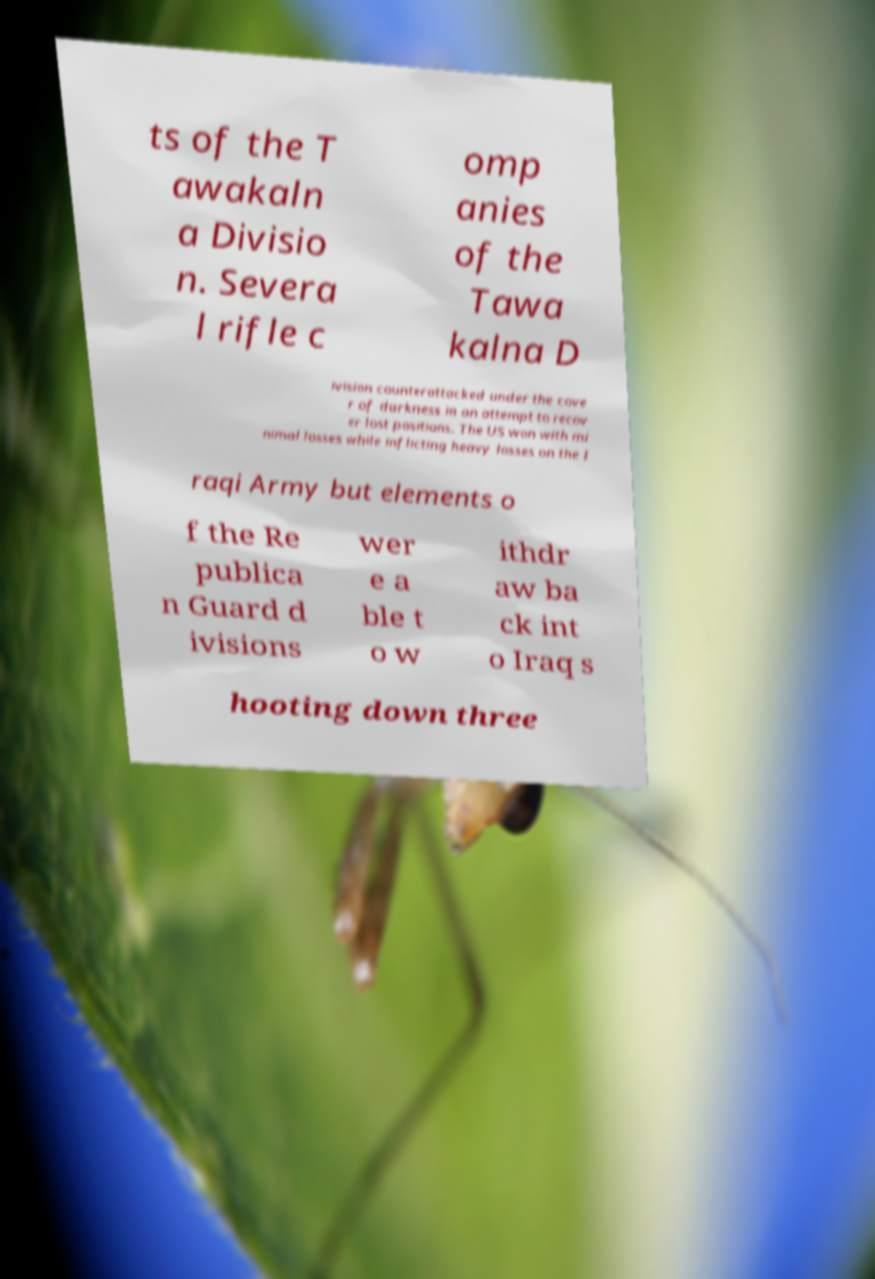What messages or text are displayed in this image? I need them in a readable, typed format. ts of the T awakaln a Divisio n. Severa l rifle c omp anies of the Tawa kalna D ivision counterattacked under the cove r of darkness in an attempt to recov er lost positions. The US won with mi nimal losses while inflicting heavy losses on the I raqi Army but elements o f the Re publica n Guard d ivisions wer e a ble t o w ithdr aw ba ck int o Iraq s hooting down three 